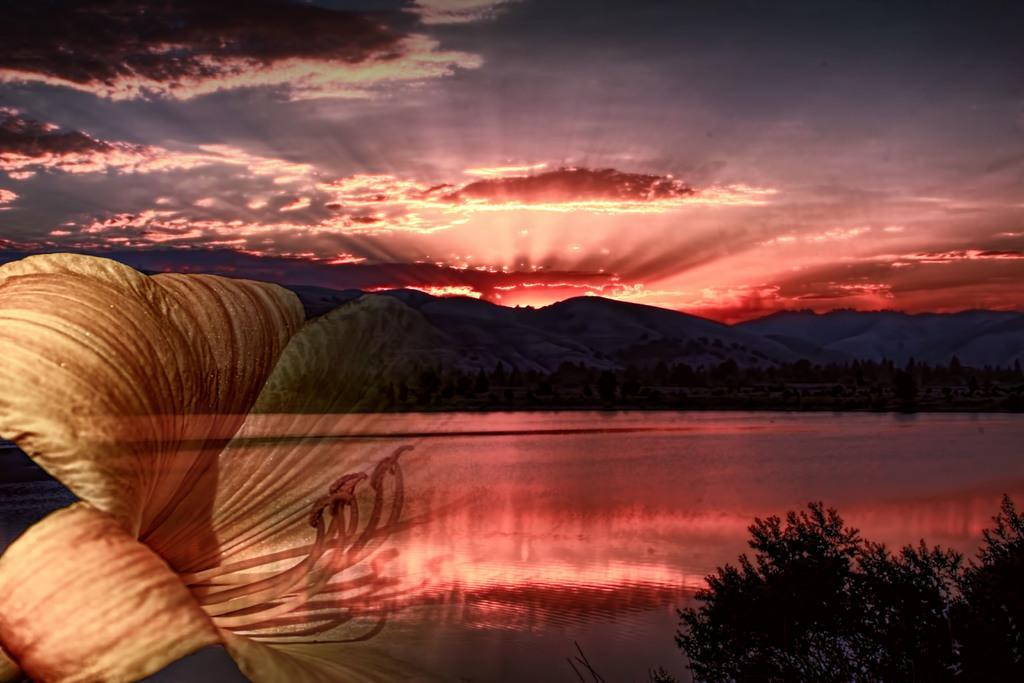Please provide a concise description of this image. This is an edited image. We can see trees, hills, water and the sky. On the left side of the image, there is a flower. 